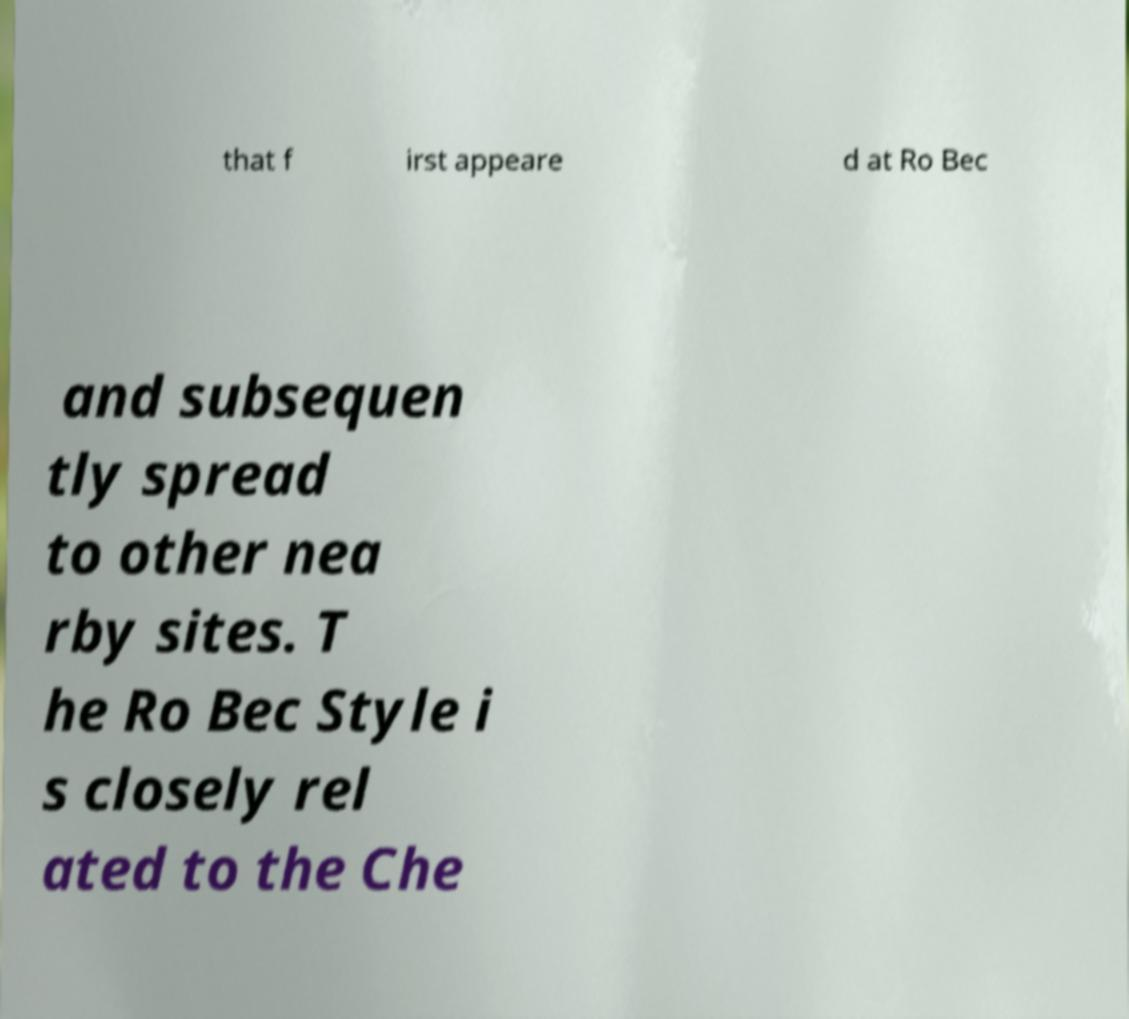Please read and relay the text visible in this image. What does it say? that f irst appeare d at Ro Bec and subsequen tly spread to other nea rby sites. T he Ro Bec Style i s closely rel ated to the Che 